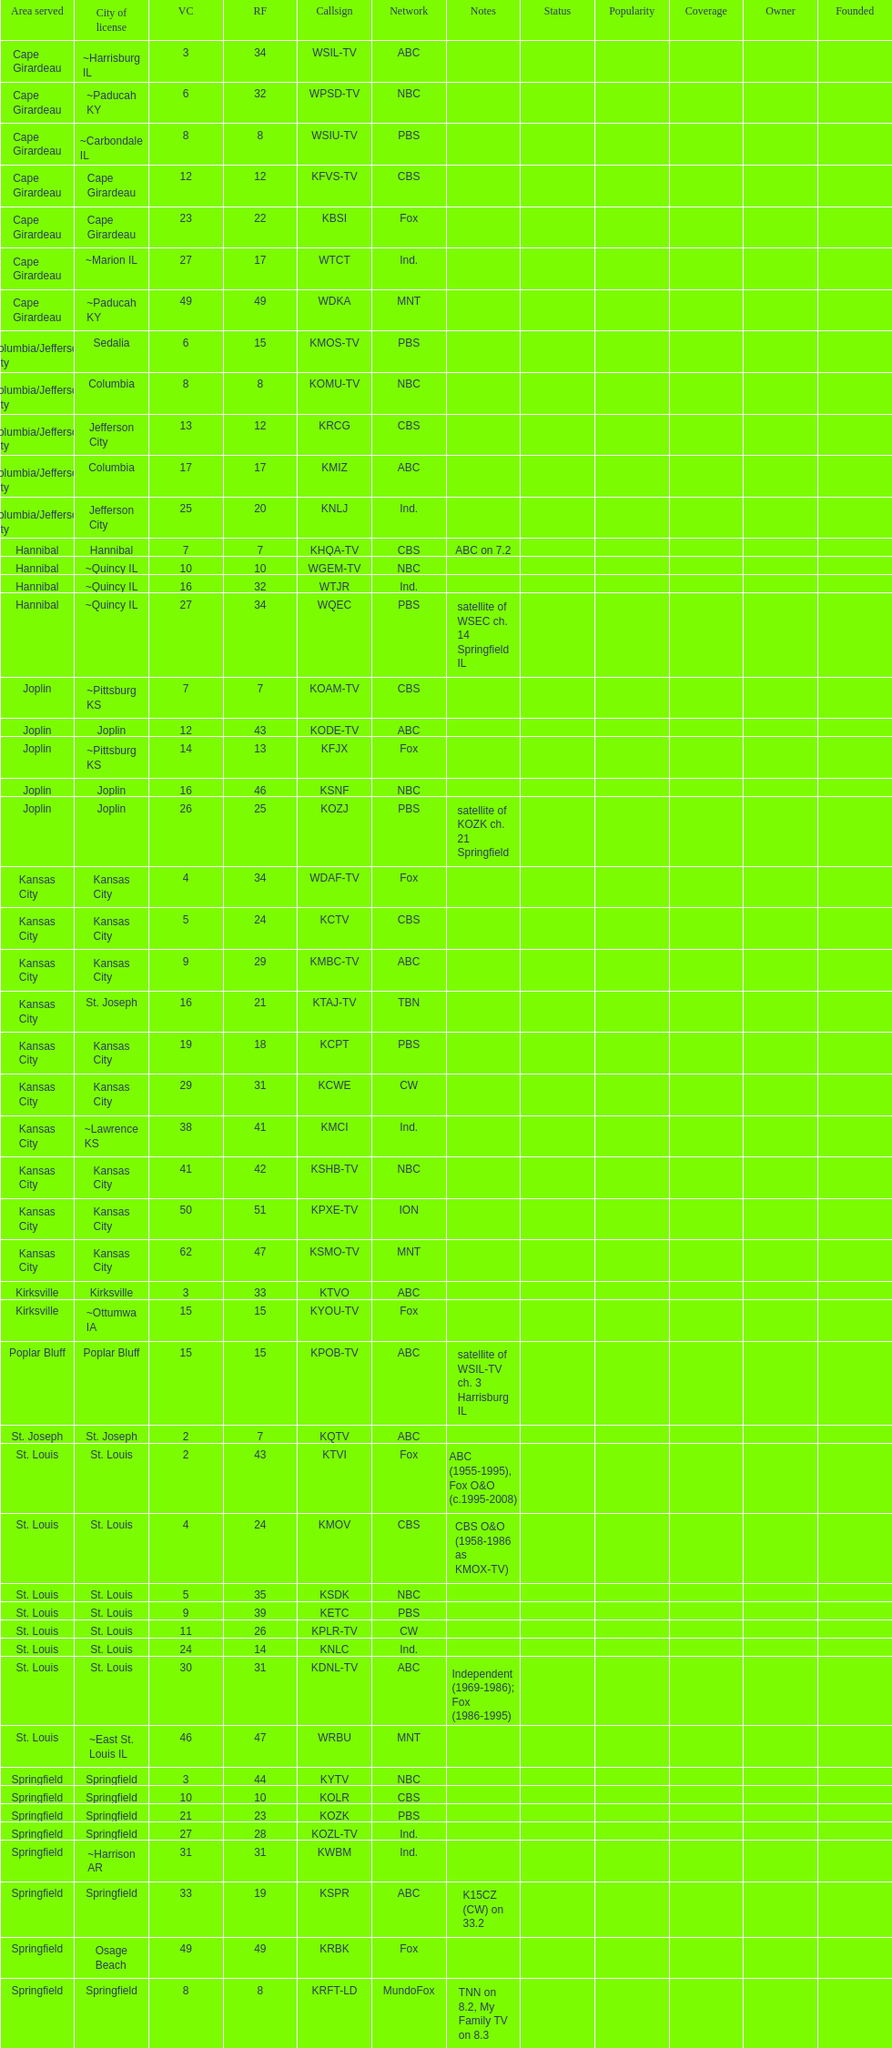Could you parse the entire table? {'header': ['Area served', 'City of license', 'VC', 'RF', 'Callsign', 'Network', 'Notes', 'Status', 'Popularity', 'Coverage', 'Owner', 'Founded'], 'rows': [['Cape Girardeau', '~Harrisburg IL', '3', '34', 'WSIL-TV', 'ABC', '', '', '', '', '', ''], ['Cape Girardeau', '~Paducah KY', '6', '32', 'WPSD-TV', 'NBC', '', '', '', '', '', ''], ['Cape Girardeau', '~Carbondale IL', '8', '8', 'WSIU-TV', 'PBS', '', '', '', '', '', ''], ['Cape Girardeau', 'Cape Girardeau', '12', '12', 'KFVS-TV', 'CBS', '', '', '', '', '', ''], ['Cape Girardeau', 'Cape Girardeau', '23', '22', 'KBSI', 'Fox', '', '', '', '', '', ''], ['Cape Girardeau', '~Marion IL', '27', '17', 'WTCT', 'Ind.', '', '', '', '', '', ''], ['Cape Girardeau', '~Paducah KY', '49', '49', 'WDKA', 'MNT', '', '', '', '', '', ''], ['Columbia/Jefferson City', 'Sedalia', '6', '15', 'KMOS-TV', 'PBS', '', '', '', '', '', ''], ['Columbia/Jefferson City', 'Columbia', '8', '8', 'KOMU-TV', 'NBC', '', '', '', '', '', ''], ['Columbia/Jefferson City', 'Jefferson City', '13', '12', 'KRCG', 'CBS', '', '', '', '', '', ''], ['Columbia/Jefferson City', 'Columbia', '17', '17', 'KMIZ', 'ABC', '', '', '', '', '', ''], ['Columbia/Jefferson City', 'Jefferson City', '25', '20', 'KNLJ', 'Ind.', '', '', '', '', '', ''], ['Hannibal', 'Hannibal', '7', '7', 'KHQA-TV', 'CBS', 'ABC on 7.2', '', '', '', '', ''], ['Hannibal', '~Quincy IL', '10', '10', 'WGEM-TV', 'NBC', '', '', '', '', '', ''], ['Hannibal', '~Quincy IL', '16', '32', 'WTJR', 'Ind.', '', '', '', '', '', ''], ['Hannibal', '~Quincy IL', '27', '34', 'WQEC', 'PBS', 'satellite of WSEC ch. 14 Springfield IL', '', '', '', '', ''], ['Joplin', '~Pittsburg KS', '7', '7', 'KOAM-TV', 'CBS', '', '', '', '', '', ''], ['Joplin', 'Joplin', '12', '43', 'KODE-TV', 'ABC', '', '', '', '', '', ''], ['Joplin', '~Pittsburg KS', '14', '13', 'KFJX', 'Fox', '', '', '', '', '', ''], ['Joplin', 'Joplin', '16', '46', 'KSNF', 'NBC', '', '', '', '', '', ''], ['Joplin', 'Joplin', '26', '25', 'KOZJ', 'PBS', 'satellite of KOZK ch. 21 Springfield', '', '', '', '', ''], ['Kansas City', 'Kansas City', '4', '34', 'WDAF-TV', 'Fox', '', '', '', '', '', ''], ['Kansas City', 'Kansas City', '5', '24', 'KCTV', 'CBS', '', '', '', '', '', ''], ['Kansas City', 'Kansas City', '9', '29', 'KMBC-TV', 'ABC', '', '', '', '', '', ''], ['Kansas City', 'St. Joseph', '16', '21', 'KTAJ-TV', 'TBN', '', '', '', '', '', ''], ['Kansas City', 'Kansas City', '19', '18', 'KCPT', 'PBS', '', '', '', '', '', ''], ['Kansas City', 'Kansas City', '29', '31', 'KCWE', 'CW', '', '', '', '', '', ''], ['Kansas City', '~Lawrence KS', '38', '41', 'KMCI', 'Ind.', '', '', '', '', '', ''], ['Kansas City', 'Kansas City', '41', '42', 'KSHB-TV', 'NBC', '', '', '', '', '', ''], ['Kansas City', 'Kansas City', '50', '51', 'KPXE-TV', 'ION', '', '', '', '', '', ''], ['Kansas City', 'Kansas City', '62', '47', 'KSMO-TV', 'MNT', '', '', '', '', '', ''], ['Kirksville', 'Kirksville', '3', '33', 'KTVO', 'ABC', '', '', '', '', '', ''], ['Kirksville', '~Ottumwa IA', '15', '15', 'KYOU-TV', 'Fox', '', '', '', '', '', ''], ['Poplar Bluff', 'Poplar Bluff', '15', '15', 'KPOB-TV', 'ABC', 'satellite of WSIL-TV ch. 3 Harrisburg IL', '', '', '', '', ''], ['St. Joseph', 'St. Joseph', '2', '7', 'KQTV', 'ABC', '', '', '', '', '', ''], ['St. Louis', 'St. Louis', '2', '43', 'KTVI', 'Fox', 'ABC (1955-1995), Fox O&O (c.1995-2008)', '', '', '', '', ''], ['St. Louis', 'St. Louis', '4', '24', 'KMOV', 'CBS', 'CBS O&O (1958-1986 as KMOX-TV)', '', '', '', '', ''], ['St. Louis', 'St. Louis', '5', '35', 'KSDK', 'NBC', '', '', '', '', '', ''], ['St. Louis', 'St. Louis', '9', '39', 'KETC', 'PBS', '', '', '', '', '', ''], ['St. Louis', 'St. Louis', '11', '26', 'KPLR-TV', 'CW', '', '', '', '', '', ''], ['St. Louis', 'St. Louis', '24', '14', 'KNLC', 'Ind.', '', '', '', '', '', ''], ['St. Louis', 'St. Louis', '30', '31', 'KDNL-TV', 'ABC', 'Independent (1969-1986); Fox (1986-1995)', '', '', '', '', ''], ['St. Louis', '~East St. Louis IL', '46', '47', 'WRBU', 'MNT', '', '', '', '', '', ''], ['Springfield', 'Springfield', '3', '44', 'KYTV', 'NBC', '', '', '', '', '', ''], ['Springfield', 'Springfield', '10', '10', 'KOLR', 'CBS', '', '', '', '', '', ''], ['Springfield', 'Springfield', '21', '23', 'KOZK', 'PBS', '', '', '', '', '', ''], ['Springfield', 'Springfield', '27', '28', 'KOZL-TV', 'Ind.', '', '', '', '', '', ''], ['Springfield', '~Harrison AR', '31', '31', 'KWBM', 'Ind.', '', '', '', '', '', ''], ['Springfield', 'Springfield', '33', '19', 'KSPR', 'ABC', 'K15CZ (CW) on 33.2', '', '', '', '', ''], ['Springfield', 'Osage Beach', '49', '49', 'KRBK', 'Fox', '', '', '', '', '', ''], ['Springfield', 'Springfield', '8', '8', 'KRFT-LD', 'MundoFox', 'TNN on 8.2, My Family TV on 8.3', '', '', '', '', '']]} How many areas have at least 5 stations? 6. 